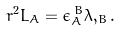Convert formula to latex. <formula><loc_0><loc_0><loc_500><loc_500>r ^ { 2 } L _ { A } = \epsilon _ { A } ^ { \, B } \lambda , _ { B } .</formula> 